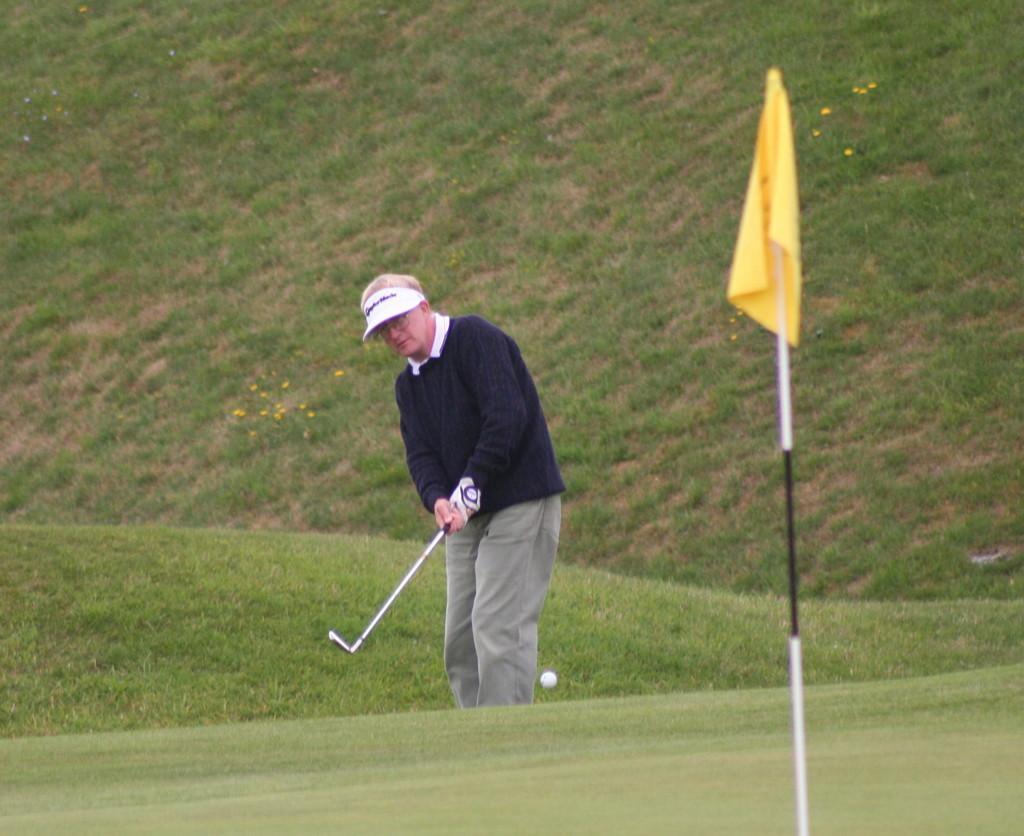Please provide a concise description of this image. In the center of the image there is a person playing golf. In the bottom of the image there is grass. There is a flag. 